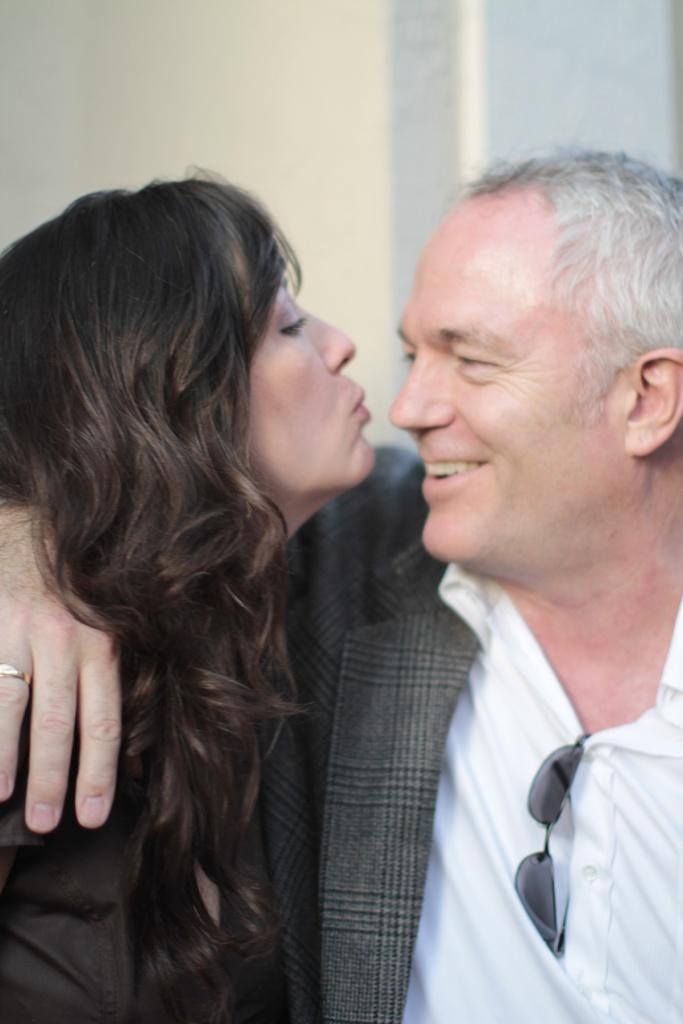In one or two sentences, can you explain what this image depicts? In this image in the right there is a man wearing white shirt. He is smiling. In the left there is a lady. In the background there is a wall. 